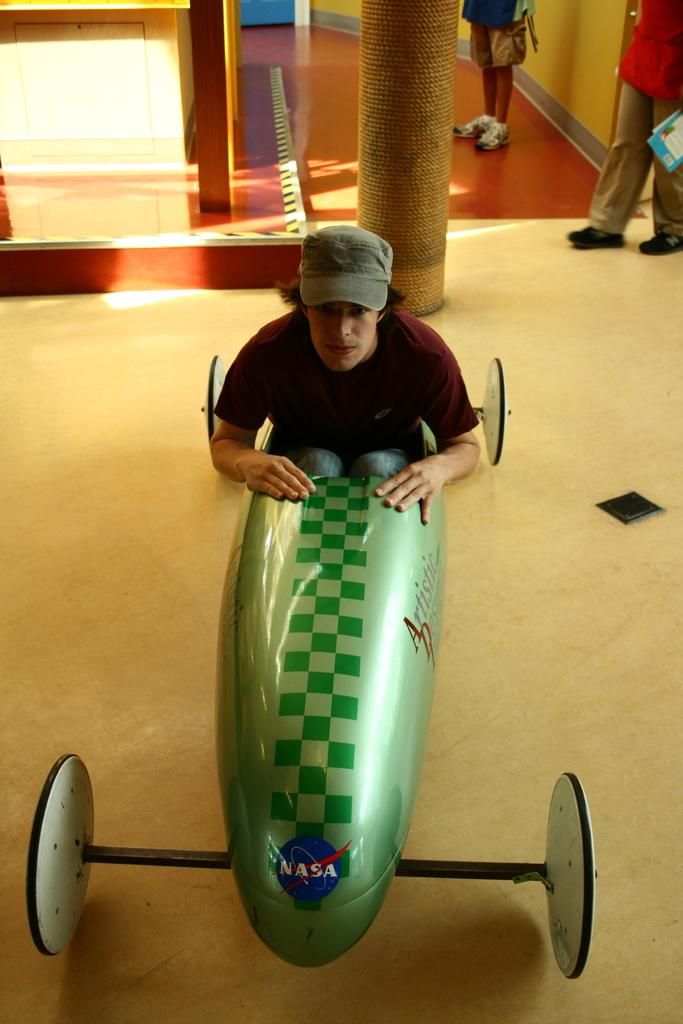<image>
Relay a brief, clear account of the picture shown. a man in a soap box with the word Artistic on the side 